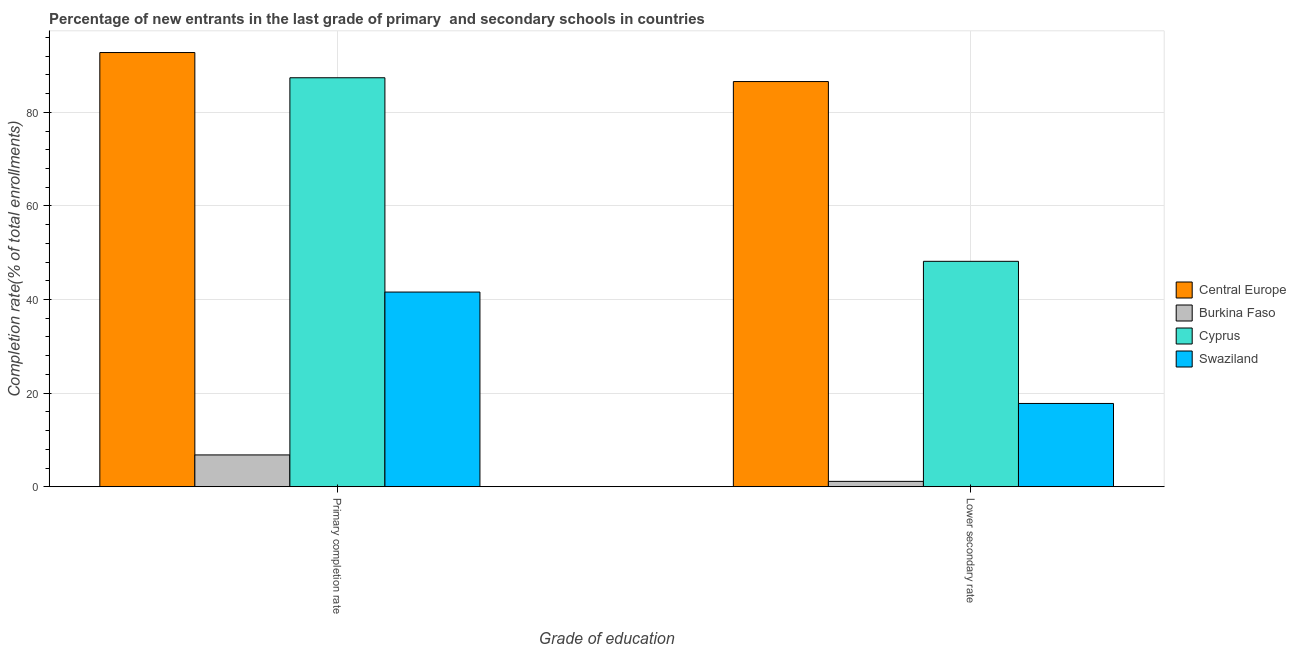How many groups of bars are there?
Make the answer very short. 2. Are the number of bars per tick equal to the number of legend labels?
Provide a short and direct response. Yes. Are the number of bars on each tick of the X-axis equal?
Keep it short and to the point. Yes. How many bars are there on the 1st tick from the left?
Ensure brevity in your answer.  4. How many bars are there on the 1st tick from the right?
Make the answer very short. 4. What is the label of the 2nd group of bars from the left?
Keep it short and to the point. Lower secondary rate. What is the completion rate in primary schools in Central Europe?
Keep it short and to the point. 92.77. Across all countries, what is the maximum completion rate in primary schools?
Give a very brief answer. 92.77. Across all countries, what is the minimum completion rate in primary schools?
Provide a succinct answer. 6.79. In which country was the completion rate in primary schools maximum?
Provide a succinct answer. Central Europe. In which country was the completion rate in secondary schools minimum?
Your answer should be very brief. Burkina Faso. What is the total completion rate in primary schools in the graph?
Keep it short and to the point. 228.53. What is the difference between the completion rate in primary schools in Swaziland and that in Central Europe?
Keep it short and to the point. -51.17. What is the difference between the completion rate in primary schools in Cyprus and the completion rate in secondary schools in Burkina Faso?
Provide a short and direct response. 86.23. What is the average completion rate in secondary schools per country?
Your answer should be compact. 38.41. What is the difference between the completion rate in primary schools and completion rate in secondary schools in Central Europe?
Provide a succinct answer. 6.2. What is the ratio of the completion rate in primary schools in Cyprus to that in Swaziland?
Provide a short and direct response. 2.1. What does the 3rd bar from the left in Lower secondary rate represents?
Make the answer very short. Cyprus. What does the 4th bar from the right in Lower secondary rate represents?
Provide a succinct answer. Central Europe. How many countries are there in the graph?
Keep it short and to the point. 4. What is the difference between two consecutive major ticks on the Y-axis?
Make the answer very short. 20. How many legend labels are there?
Offer a very short reply. 4. How are the legend labels stacked?
Make the answer very short. Vertical. What is the title of the graph?
Provide a short and direct response. Percentage of new entrants in the last grade of primary  and secondary schools in countries. What is the label or title of the X-axis?
Provide a succinct answer. Grade of education. What is the label or title of the Y-axis?
Keep it short and to the point. Completion rate(% of total enrollments). What is the Completion rate(% of total enrollments) of Central Europe in Primary completion rate?
Provide a succinct answer. 92.77. What is the Completion rate(% of total enrollments) of Burkina Faso in Primary completion rate?
Your answer should be compact. 6.79. What is the Completion rate(% of total enrollments) of Cyprus in Primary completion rate?
Provide a succinct answer. 87.38. What is the Completion rate(% of total enrollments) of Swaziland in Primary completion rate?
Make the answer very short. 41.59. What is the Completion rate(% of total enrollments) in Central Europe in Lower secondary rate?
Give a very brief answer. 86.57. What is the Completion rate(% of total enrollments) in Burkina Faso in Lower secondary rate?
Offer a very short reply. 1.15. What is the Completion rate(% of total enrollments) in Cyprus in Lower secondary rate?
Provide a succinct answer. 48.16. What is the Completion rate(% of total enrollments) of Swaziland in Lower secondary rate?
Your response must be concise. 17.79. Across all Grade of education, what is the maximum Completion rate(% of total enrollments) in Central Europe?
Your response must be concise. 92.77. Across all Grade of education, what is the maximum Completion rate(% of total enrollments) of Burkina Faso?
Provide a short and direct response. 6.79. Across all Grade of education, what is the maximum Completion rate(% of total enrollments) in Cyprus?
Give a very brief answer. 87.38. Across all Grade of education, what is the maximum Completion rate(% of total enrollments) of Swaziland?
Your response must be concise. 41.59. Across all Grade of education, what is the minimum Completion rate(% of total enrollments) in Central Europe?
Your response must be concise. 86.57. Across all Grade of education, what is the minimum Completion rate(% of total enrollments) in Burkina Faso?
Provide a succinct answer. 1.15. Across all Grade of education, what is the minimum Completion rate(% of total enrollments) of Cyprus?
Your answer should be very brief. 48.16. Across all Grade of education, what is the minimum Completion rate(% of total enrollments) of Swaziland?
Offer a terse response. 17.79. What is the total Completion rate(% of total enrollments) in Central Europe in the graph?
Offer a terse response. 179.33. What is the total Completion rate(% of total enrollments) of Burkina Faso in the graph?
Ensure brevity in your answer.  7.94. What is the total Completion rate(% of total enrollments) of Cyprus in the graph?
Ensure brevity in your answer.  135.54. What is the total Completion rate(% of total enrollments) of Swaziland in the graph?
Your response must be concise. 59.38. What is the difference between the Completion rate(% of total enrollments) of Central Europe in Primary completion rate and that in Lower secondary rate?
Your response must be concise. 6.2. What is the difference between the Completion rate(% of total enrollments) of Burkina Faso in Primary completion rate and that in Lower secondary rate?
Provide a short and direct response. 5.65. What is the difference between the Completion rate(% of total enrollments) of Cyprus in Primary completion rate and that in Lower secondary rate?
Offer a terse response. 39.22. What is the difference between the Completion rate(% of total enrollments) in Swaziland in Primary completion rate and that in Lower secondary rate?
Offer a very short reply. 23.81. What is the difference between the Completion rate(% of total enrollments) of Central Europe in Primary completion rate and the Completion rate(% of total enrollments) of Burkina Faso in Lower secondary rate?
Your answer should be compact. 91.62. What is the difference between the Completion rate(% of total enrollments) of Central Europe in Primary completion rate and the Completion rate(% of total enrollments) of Cyprus in Lower secondary rate?
Offer a very short reply. 44.61. What is the difference between the Completion rate(% of total enrollments) in Central Europe in Primary completion rate and the Completion rate(% of total enrollments) in Swaziland in Lower secondary rate?
Your response must be concise. 74.98. What is the difference between the Completion rate(% of total enrollments) in Burkina Faso in Primary completion rate and the Completion rate(% of total enrollments) in Cyprus in Lower secondary rate?
Provide a short and direct response. -41.37. What is the difference between the Completion rate(% of total enrollments) in Burkina Faso in Primary completion rate and the Completion rate(% of total enrollments) in Swaziland in Lower secondary rate?
Your answer should be compact. -11. What is the difference between the Completion rate(% of total enrollments) in Cyprus in Primary completion rate and the Completion rate(% of total enrollments) in Swaziland in Lower secondary rate?
Make the answer very short. 69.59. What is the average Completion rate(% of total enrollments) in Central Europe per Grade of education?
Your response must be concise. 89.67. What is the average Completion rate(% of total enrollments) of Burkina Faso per Grade of education?
Ensure brevity in your answer.  3.97. What is the average Completion rate(% of total enrollments) of Cyprus per Grade of education?
Your answer should be very brief. 67.77. What is the average Completion rate(% of total enrollments) in Swaziland per Grade of education?
Your answer should be compact. 29.69. What is the difference between the Completion rate(% of total enrollments) of Central Europe and Completion rate(% of total enrollments) of Burkina Faso in Primary completion rate?
Offer a terse response. 85.97. What is the difference between the Completion rate(% of total enrollments) of Central Europe and Completion rate(% of total enrollments) of Cyprus in Primary completion rate?
Offer a very short reply. 5.39. What is the difference between the Completion rate(% of total enrollments) in Central Europe and Completion rate(% of total enrollments) in Swaziland in Primary completion rate?
Your answer should be very brief. 51.17. What is the difference between the Completion rate(% of total enrollments) in Burkina Faso and Completion rate(% of total enrollments) in Cyprus in Primary completion rate?
Provide a succinct answer. -80.58. What is the difference between the Completion rate(% of total enrollments) of Burkina Faso and Completion rate(% of total enrollments) of Swaziland in Primary completion rate?
Make the answer very short. -34.8. What is the difference between the Completion rate(% of total enrollments) in Cyprus and Completion rate(% of total enrollments) in Swaziland in Primary completion rate?
Offer a very short reply. 45.78. What is the difference between the Completion rate(% of total enrollments) in Central Europe and Completion rate(% of total enrollments) in Burkina Faso in Lower secondary rate?
Provide a short and direct response. 85.42. What is the difference between the Completion rate(% of total enrollments) of Central Europe and Completion rate(% of total enrollments) of Cyprus in Lower secondary rate?
Your response must be concise. 38.41. What is the difference between the Completion rate(% of total enrollments) in Central Europe and Completion rate(% of total enrollments) in Swaziland in Lower secondary rate?
Offer a terse response. 68.78. What is the difference between the Completion rate(% of total enrollments) of Burkina Faso and Completion rate(% of total enrollments) of Cyprus in Lower secondary rate?
Your answer should be compact. -47.01. What is the difference between the Completion rate(% of total enrollments) in Burkina Faso and Completion rate(% of total enrollments) in Swaziland in Lower secondary rate?
Ensure brevity in your answer.  -16.64. What is the difference between the Completion rate(% of total enrollments) in Cyprus and Completion rate(% of total enrollments) in Swaziland in Lower secondary rate?
Give a very brief answer. 30.37. What is the ratio of the Completion rate(% of total enrollments) in Central Europe in Primary completion rate to that in Lower secondary rate?
Your answer should be very brief. 1.07. What is the ratio of the Completion rate(% of total enrollments) in Burkina Faso in Primary completion rate to that in Lower secondary rate?
Provide a succinct answer. 5.93. What is the ratio of the Completion rate(% of total enrollments) in Cyprus in Primary completion rate to that in Lower secondary rate?
Offer a terse response. 1.81. What is the ratio of the Completion rate(% of total enrollments) of Swaziland in Primary completion rate to that in Lower secondary rate?
Your answer should be very brief. 2.34. What is the difference between the highest and the second highest Completion rate(% of total enrollments) of Central Europe?
Offer a terse response. 6.2. What is the difference between the highest and the second highest Completion rate(% of total enrollments) of Burkina Faso?
Your response must be concise. 5.65. What is the difference between the highest and the second highest Completion rate(% of total enrollments) of Cyprus?
Give a very brief answer. 39.22. What is the difference between the highest and the second highest Completion rate(% of total enrollments) in Swaziland?
Keep it short and to the point. 23.81. What is the difference between the highest and the lowest Completion rate(% of total enrollments) of Central Europe?
Your answer should be compact. 6.2. What is the difference between the highest and the lowest Completion rate(% of total enrollments) in Burkina Faso?
Your answer should be compact. 5.65. What is the difference between the highest and the lowest Completion rate(% of total enrollments) in Cyprus?
Ensure brevity in your answer.  39.22. What is the difference between the highest and the lowest Completion rate(% of total enrollments) of Swaziland?
Your response must be concise. 23.81. 